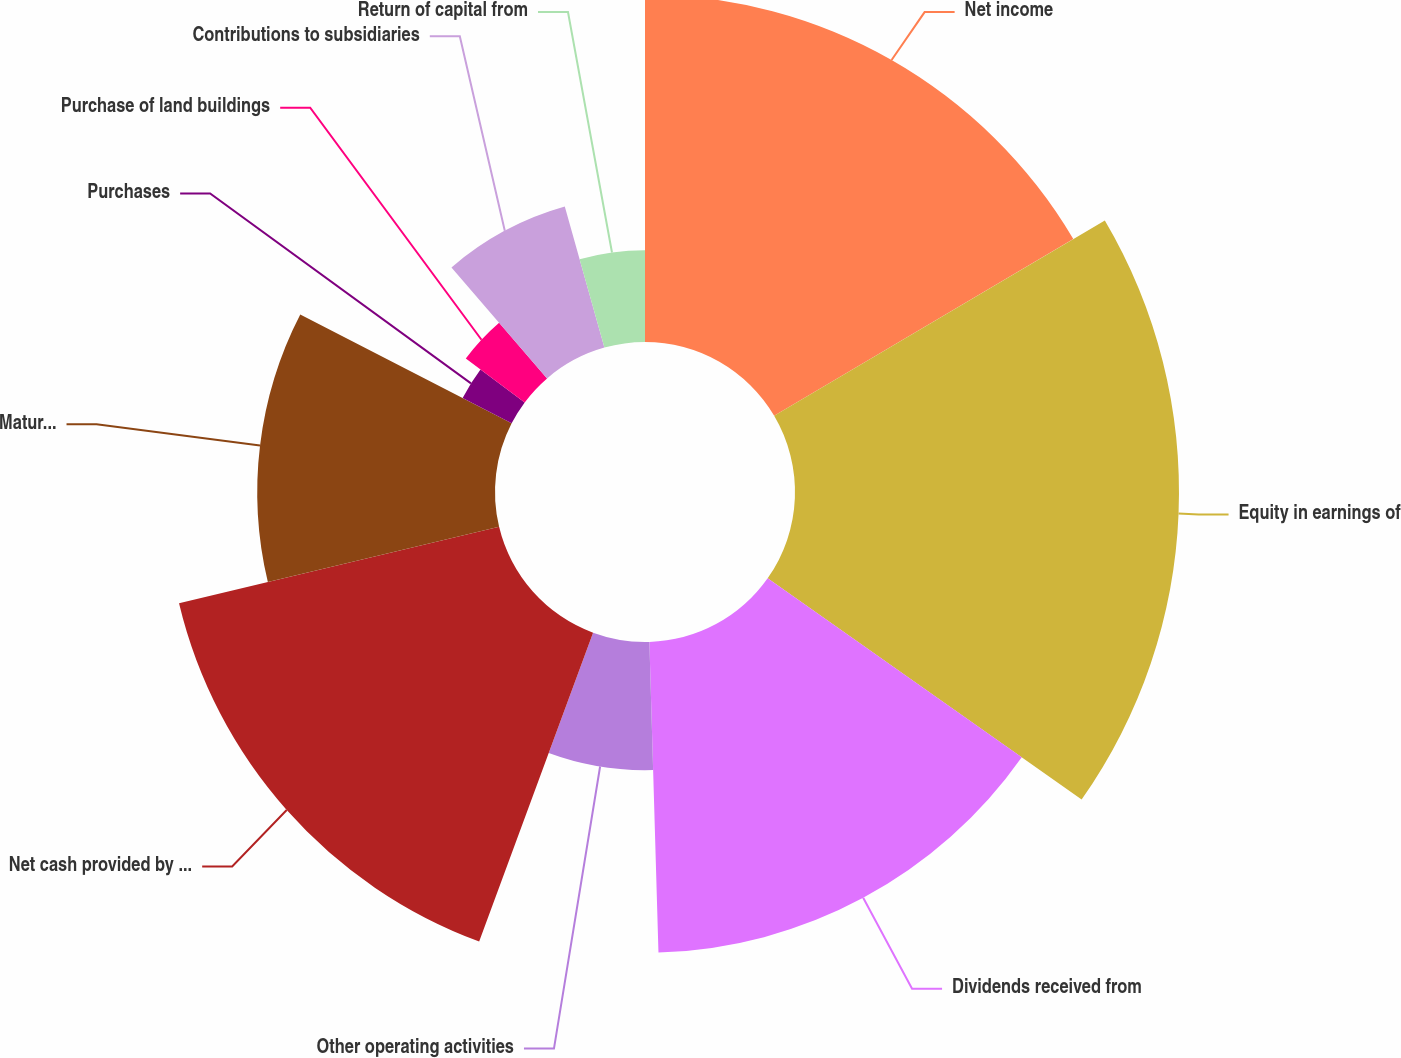Convert chart. <chart><loc_0><loc_0><loc_500><loc_500><pie_chart><fcel>Net income<fcel>Equity in earnings of<fcel>Dividends received from<fcel>Other operating activities<fcel>Net cash provided by operating<fcel>Maturities sinking fund<fcel>Purchases<fcel>Purchase of land buildings<fcel>Contributions to subsidiaries<fcel>Return of capital from<nl><fcel>16.51%<fcel>18.25%<fcel>14.77%<fcel>6.09%<fcel>15.64%<fcel>11.3%<fcel>2.62%<fcel>3.49%<fcel>6.96%<fcel>4.36%<nl></chart> 